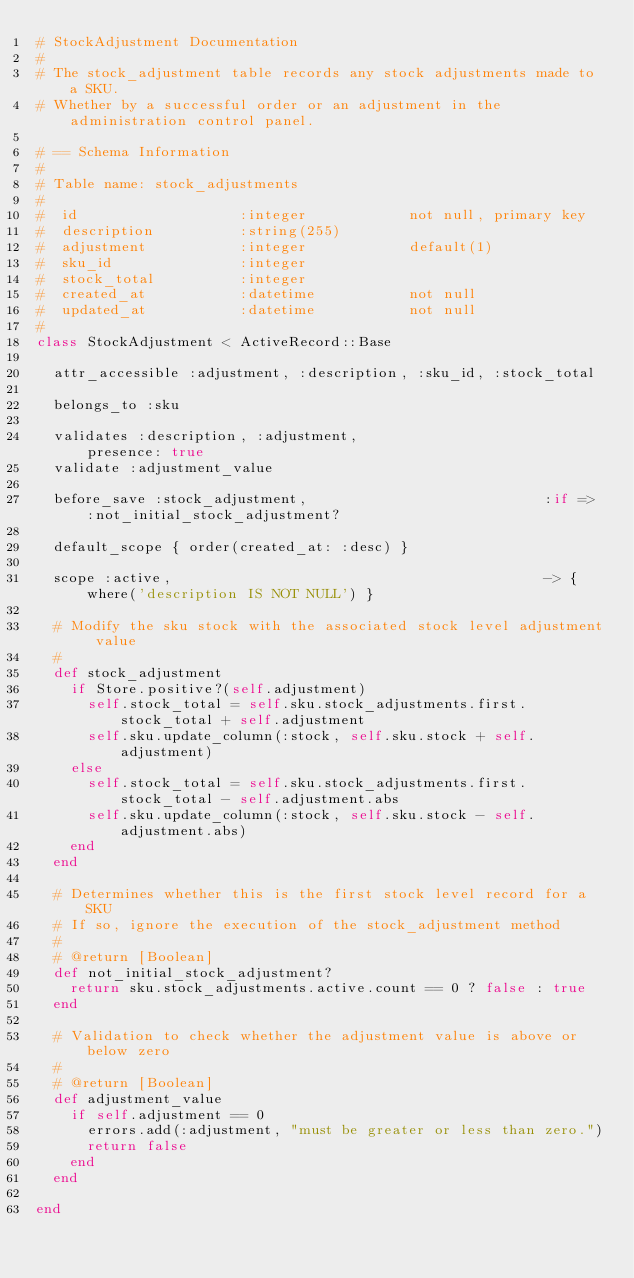<code> <loc_0><loc_0><loc_500><loc_500><_Ruby_># StockAdjustment Documentation
#
# The stock_adjustment table records any stock adjustments made to a SKU.
# Whether by a successful order or an adjustment in the administration control panel.

# == Schema Information
#
# Table name: stock_adjustments
#
#  id                   :integer            not null, primary key
#  description          :string(255)        
#  adjustment           :integer            default(1)
#  sku_id               :integer            
#  stock_total          :integer
#  created_at           :datetime           not null
#  updated_at           :datetime           not null
#
class StockAdjustment < ActiveRecord::Base

  attr_accessible :adjustment, :description, :sku_id, :stock_total

  belongs_to :sku

  validates :description, :adjustment,                      presence: true
  validate :adjustment_value

  before_save :stock_adjustment,                            :if => :not_initial_stock_adjustment?

  default_scope { order(created_at: :desc) }

  scope :active,                                            -> { where('description IS NOT NULL') }

  # Modify the sku stock with the associated stock level adjustment value
  #
  def stock_adjustment
    if Store.positive?(self.adjustment)
      self.stock_total = self.sku.stock_adjustments.first.stock_total + self.adjustment
      self.sku.update_column(:stock, self.sku.stock + self.adjustment)
    else
      self.stock_total = self.sku.stock_adjustments.first.stock_total - self.adjustment.abs
      self.sku.update_column(:stock, self.sku.stock - self.adjustment.abs)
    end
  end

  # Determines whether this is the first stock level record for a SKU
  # If so, ignore the execution of the stock_adjustment method
  #
  # @return [Boolean]
  def not_initial_stock_adjustment?
    return sku.stock_adjustments.active.count == 0 ? false : true
  end

  # Validation to check whether the adjustment value is above or below zero
  #
  # @return [Boolean]
  def adjustment_value
    if self.adjustment == 0
      errors.add(:adjustment, "must be greater or less than zero.")
      return false
    end
  end

end
</code> 